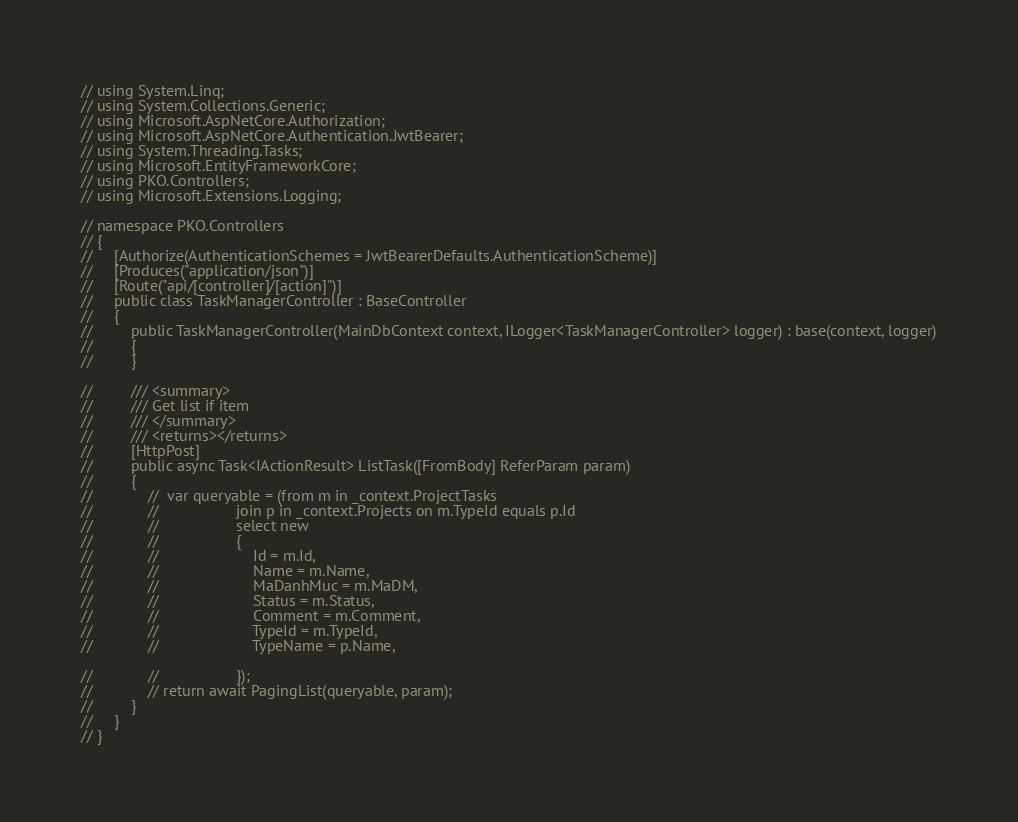<code> <loc_0><loc_0><loc_500><loc_500><_C#_>// using System.Linq;
// using System.Collections.Generic;
// using Microsoft.AspNetCore.Authorization;
// using Microsoft.AspNetCore.Authentication.JwtBearer;
// using System.Threading.Tasks;
// using Microsoft.EntityFrameworkCore;
// using PKO.Controllers;
// using Microsoft.Extensions.Logging;

// namespace PKO.Controllers
// {
//     [Authorize(AuthenticationSchemes = JwtBearerDefaults.AuthenticationScheme)]
//     [Produces("application/json")]
//     [Route("api/[controller]/[action]")]
//     public class TaskManagerController : BaseController
//     {
//         public TaskManagerController(MainDbContext context, ILogger<TaskManagerController> logger) : base(context, logger)
//         {
//         }

//         /// <summary>
//         /// Get list if item
//         /// </summary>
//         /// <returns></returns>
//         [HttpPost]
//         public async Task<IActionResult> ListTask([FromBody] ReferParam param)
//         {
//             //  var queryable = (from m in _context.ProjectTasks
//             //                  join p in _context.Projects on m.TypeId equals p.Id
//             //                  select new
//             //                  {
//             //                      Id = m.Id,
//             //                      Name = m.Name,
//             //                      MaDanhMuc = m.MaDM,
//             //                      Status = m.Status,
//             //                      Comment = m.Comment,
//             //                      TypeId = m.TypeId,
//             //                      TypeName = p.Name,

//             //                  });
//             // return await PagingList(queryable, param);
//         }
//     }
// }</code> 